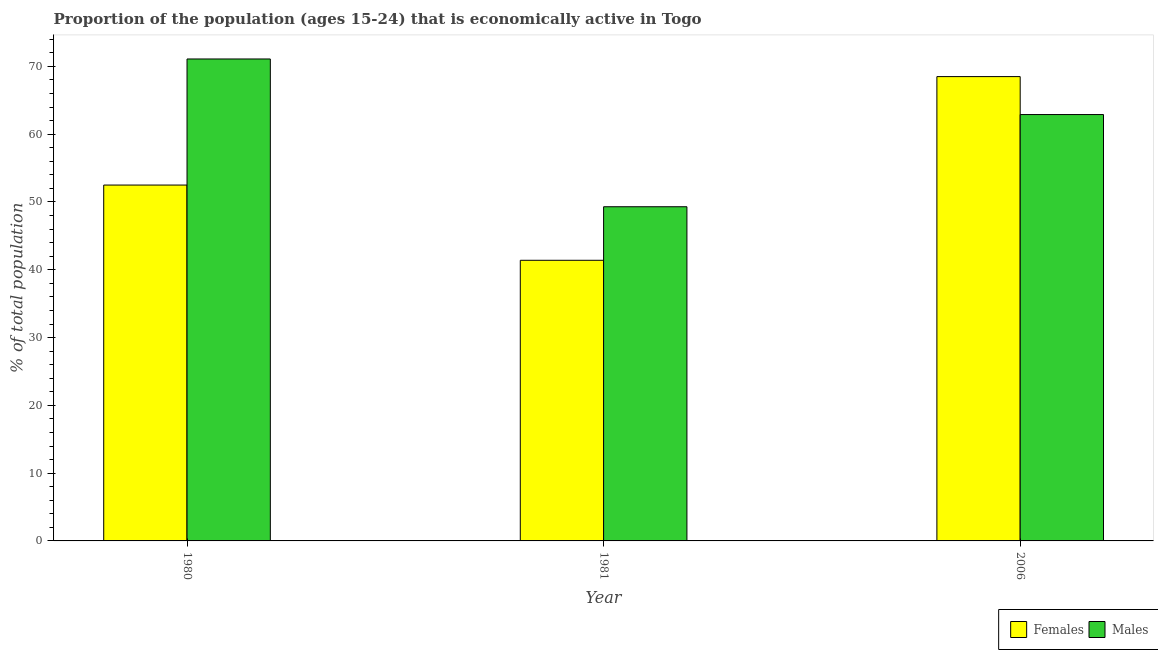How many different coloured bars are there?
Provide a succinct answer. 2. How many groups of bars are there?
Your answer should be compact. 3. Are the number of bars on each tick of the X-axis equal?
Your answer should be very brief. Yes. How many bars are there on the 3rd tick from the left?
Provide a short and direct response. 2. How many bars are there on the 2nd tick from the right?
Ensure brevity in your answer.  2. In how many cases, is the number of bars for a given year not equal to the number of legend labels?
Offer a terse response. 0. What is the percentage of economically active male population in 1980?
Ensure brevity in your answer.  71.1. Across all years, what is the maximum percentage of economically active male population?
Make the answer very short. 71.1. Across all years, what is the minimum percentage of economically active female population?
Offer a very short reply. 41.4. In which year was the percentage of economically active female population maximum?
Your answer should be very brief. 2006. In which year was the percentage of economically active male population minimum?
Your response must be concise. 1981. What is the total percentage of economically active male population in the graph?
Offer a terse response. 183.3. What is the difference between the percentage of economically active female population in 1981 and that in 2006?
Make the answer very short. -27.1. What is the difference between the percentage of economically active female population in 1980 and the percentage of economically active male population in 1981?
Provide a short and direct response. 11.1. What is the average percentage of economically active male population per year?
Provide a succinct answer. 61.1. In the year 2006, what is the difference between the percentage of economically active male population and percentage of economically active female population?
Keep it short and to the point. 0. What is the ratio of the percentage of economically active female population in 1980 to that in 2006?
Ensure brevity in your answer.  0.77. Is the percentage of economically active female population in 1980 less than that in 2006?
Ensure brevity in your answer.  Yes. What is the difference between the highest and the second highest percentage of economically active male population?
Keep it short and to the point. 8.2. What is the difference between the highest and the lowest percentage of economically active male population?
Make the answer very short. 21.8. What does the 2nd bar from the left in 2006 represents?
Provide a short and direct response. Males. What does the 2nd bar from the right in 1980 represents?
Provide a short and direct response. Females. How many years are there in the graph?
Offer a very short reply. 3. Are the values on the major ticks of Y-axis written in scientific E-notation?
Your answer should be very brief. No. Where does the legend appear in the graph?
Provide a short and direct response. Bottom right. How many legend labels are there?
Your answer should be very brief. 2. How are the legend labels stacked?
Provide a succinct answer. Horizontal. What is the title of the graph?
Provide a short and direct response. Proportion of the population (ages 15-24) that is economically active in Togo. Does "Malaria" appear as one of the legend labels in the graph?
Offer a terse response. No. What is the label or title of the Y-axis?
Give a very brief answer. % of total population. What is the % of total population in Females in 1980?
Your response must be concise. 52.5. What is the % of total population in Males in 1980?
Keep it short and to the point. 71.1. What is the % of total population in Females in 1981?
Give a very brief answer. 41.4. What is the % of total population in Males in 1981?
Ensure brevity in your answer.  49.3. What is the % of total population in Females in 2006?
Provide a succinct answer. 68.5. What is the % of total population in Males in 2006?
Your response must be concise. 62.9. Across all years, what is the maximum % of total population of Females?
Ensure brevity in your answer.  68.5. Across all years, what is the maximum % of total population in Males?
Keep it short and to the point. 71.1. Across all years, what is the minimum % of total population of Females?
Offer a terse response. 41.4. Across all years, what is the minimum % of total population of Males?
Your response must be concise. 49.3. What is the total % of total population of Females in the graph?
Give a very brief answer. 162.4. What is the total % of total population of Males in the graph?
Keep it short and to the point. 183.3. What is the difference between the % of total population in Females in 1980 and that in 1981?
Your response must be concise. 11.1. What is the difference between the % of total population of Males in 1980 and that in 1981?
Offer a terse response. 21.8. What is the difference between the % of total population of Males in 1980 and that in 2006?
Provide a succinct answer. 8.2. What is the difference between the % of total population in Females in 1981 and that in 2006?
Make the answer very short. -27.1. What is the difference between the % of total population of Females in 1981 and the % of total population of Males in 2006?
Your response must be concise. -21.5. What is the average % of total population of Females per year?
Provide a succinct answer. 54.13. What is the average % of total population in Males per year?
Keep it short and to the point. 61.1. In the year 1980, what is the difference between the % of total population of Females and % of total population of Males?
Give a very brief answer. -18.6. In the year 2006, what is the difference between the % of total population in Females and % of total population in Males?
Offer a terse response. 5.6. What is the ratio of the % of total population of Females in 1980 to that in 1981?
Your answer should be compact. 1.27. What is the ratio of the % of total population in Males in 1980 to that in 1981?
Give a very brief answer. 1.44. What is the ratio of the % of total population of Females in 1980 to that in 2006?
Keep it short and to the point. 0.77. What is the ratio of the % of total population in Males in 1980 to that in 2006?
Provide a succinct answer. 1.13. What is the ratio of the % of total population of Females in 1981 to that in 2006?
Your answer should be compact. 0.6. What is the ratio of the % of total population of Males in 1981 to that in 2006?
Your answer should be very brief. 0.78. What is the difference between the highest and the second highest % of total population in Males?
Offer a terse response. 8.2. What is the difference between the highest and the lowest % of total population in Females?
Make the answer very short. 27.1. What is the difference between the highest and the lowest % of total population of Males?
Keep it short and to the point. 21.8. 